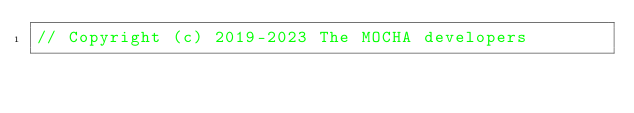Convert code to text. <code><loc_0><loc_0><loc_500><loc_500><_C_>// Copyright (c) 2019-2023 The MOCHA developers</code> 